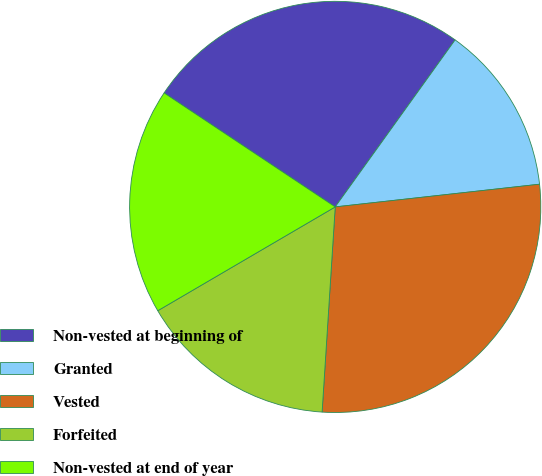Convert chart to OTSL. <chart><loc_0><loc_0><loc_500><loc_500><pie_chart><fcel>Non-vested at beginning of<fcel>Granted<fcel>Vested<fcel>Forfeited<fcel>Non-vested at end of year<nl><fcel>25.56%<fcel>13.33%<fcel>27.78%<fcel>15.56%<fcel>17.78%<nl></chart> 